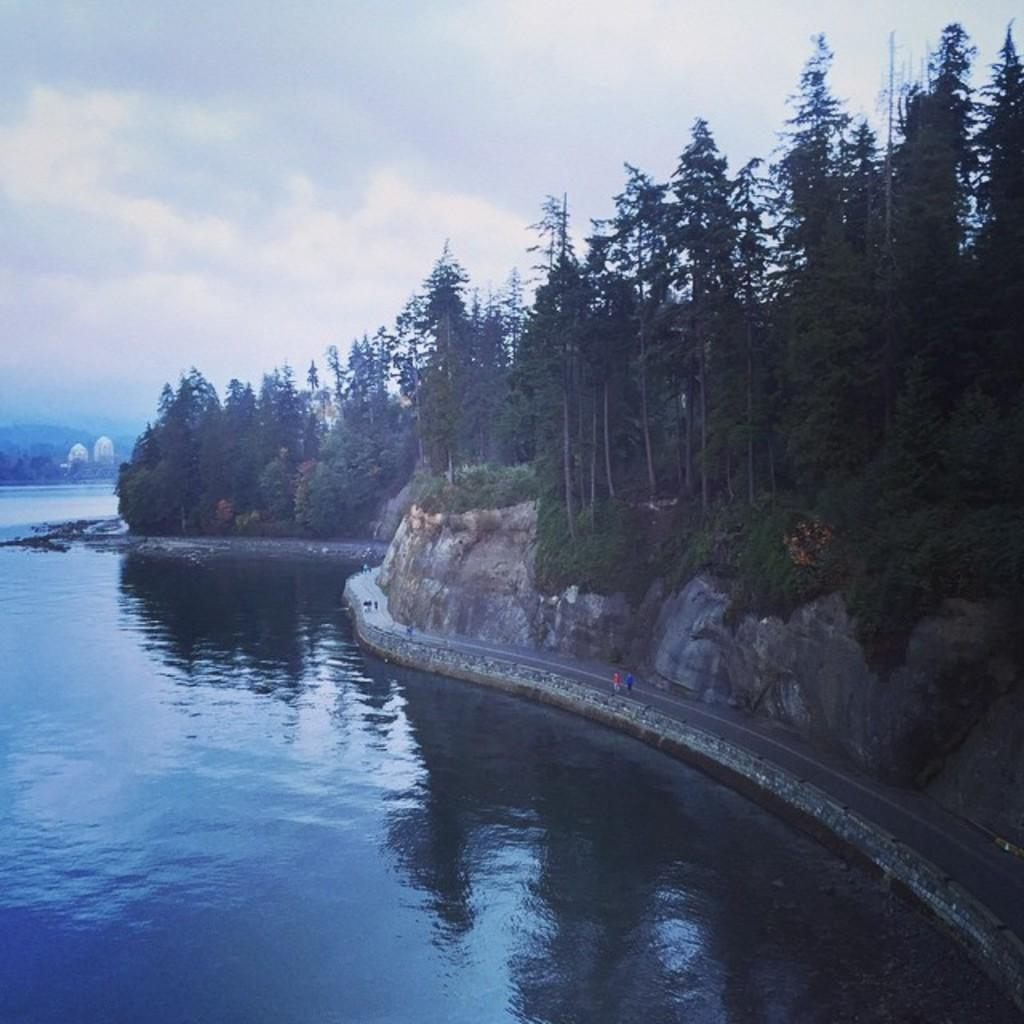What type of vegetation can be seen in the image? There are trees in the image. What natural element is present in the image? There is water in the image, and waves are present in the water. What man-made structure is visible in the image? There is a road in the image. Are there any living beings in the image? Yes, people are visible in the image. What type of ground surface is present in the image? Grass is present in the image. What additional objects can be seen in the image? Stones are in the image. What geographical features are present in the image? There are hills in the image. What is visible in the sky in the image? The sky is visible in the image, and clouds are present in the sky. How many times do the people's eyes fold in the image? There is no information about the people's eyes folding in the image. Is there any snow present in the image? No, there is no snow present in the image. 